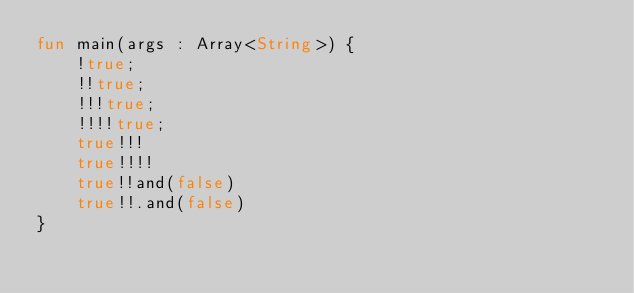Convert code to text. <code><loc_0><loc_0><loc_500><loc_500><_Kotlin_>fun main(args : Array<String>) {
    !true;
    !!true;
    !!!true;
    !!!!true;
    true!!!
    true!!!!
    true!!and(false)
    true!!.and(false)
}</code> 